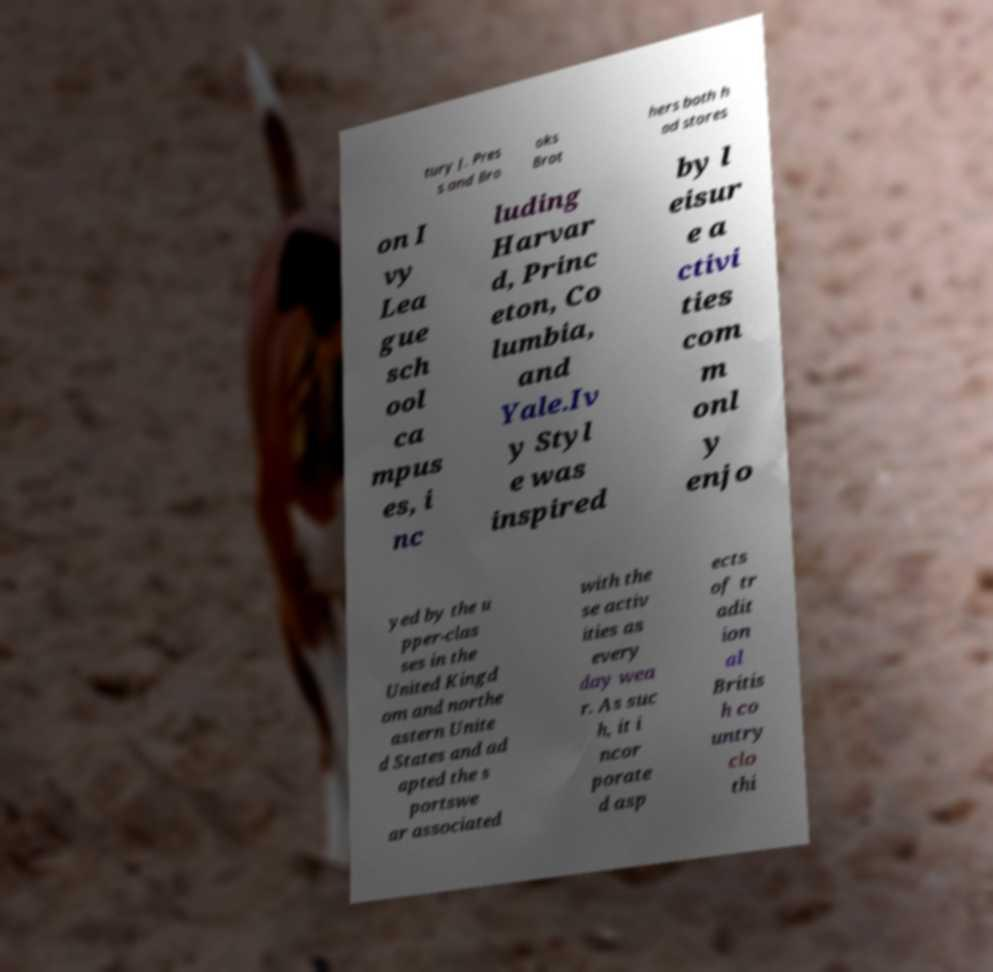Please read and relay the text visible in this image. What does it say? tury J. Pres s and Bro oks Brot hers both h ad stores on I vy Lea gue sch ool ca mpus es, i nc luding Harvar d, Princ eton, Co lumbia, and Yale.Iv y Styl e was inspired by l eisur e a ctivi ties com m onl y enjo yed by the u pper-clas ses in the United Kingd om and northe astern Unite d States and ad apted the s portswe ar associated with the se activ ities as every day wea r. As suc h, it i ncor porate d asp ects of tr adit ion al Britis h co untry clo thi 